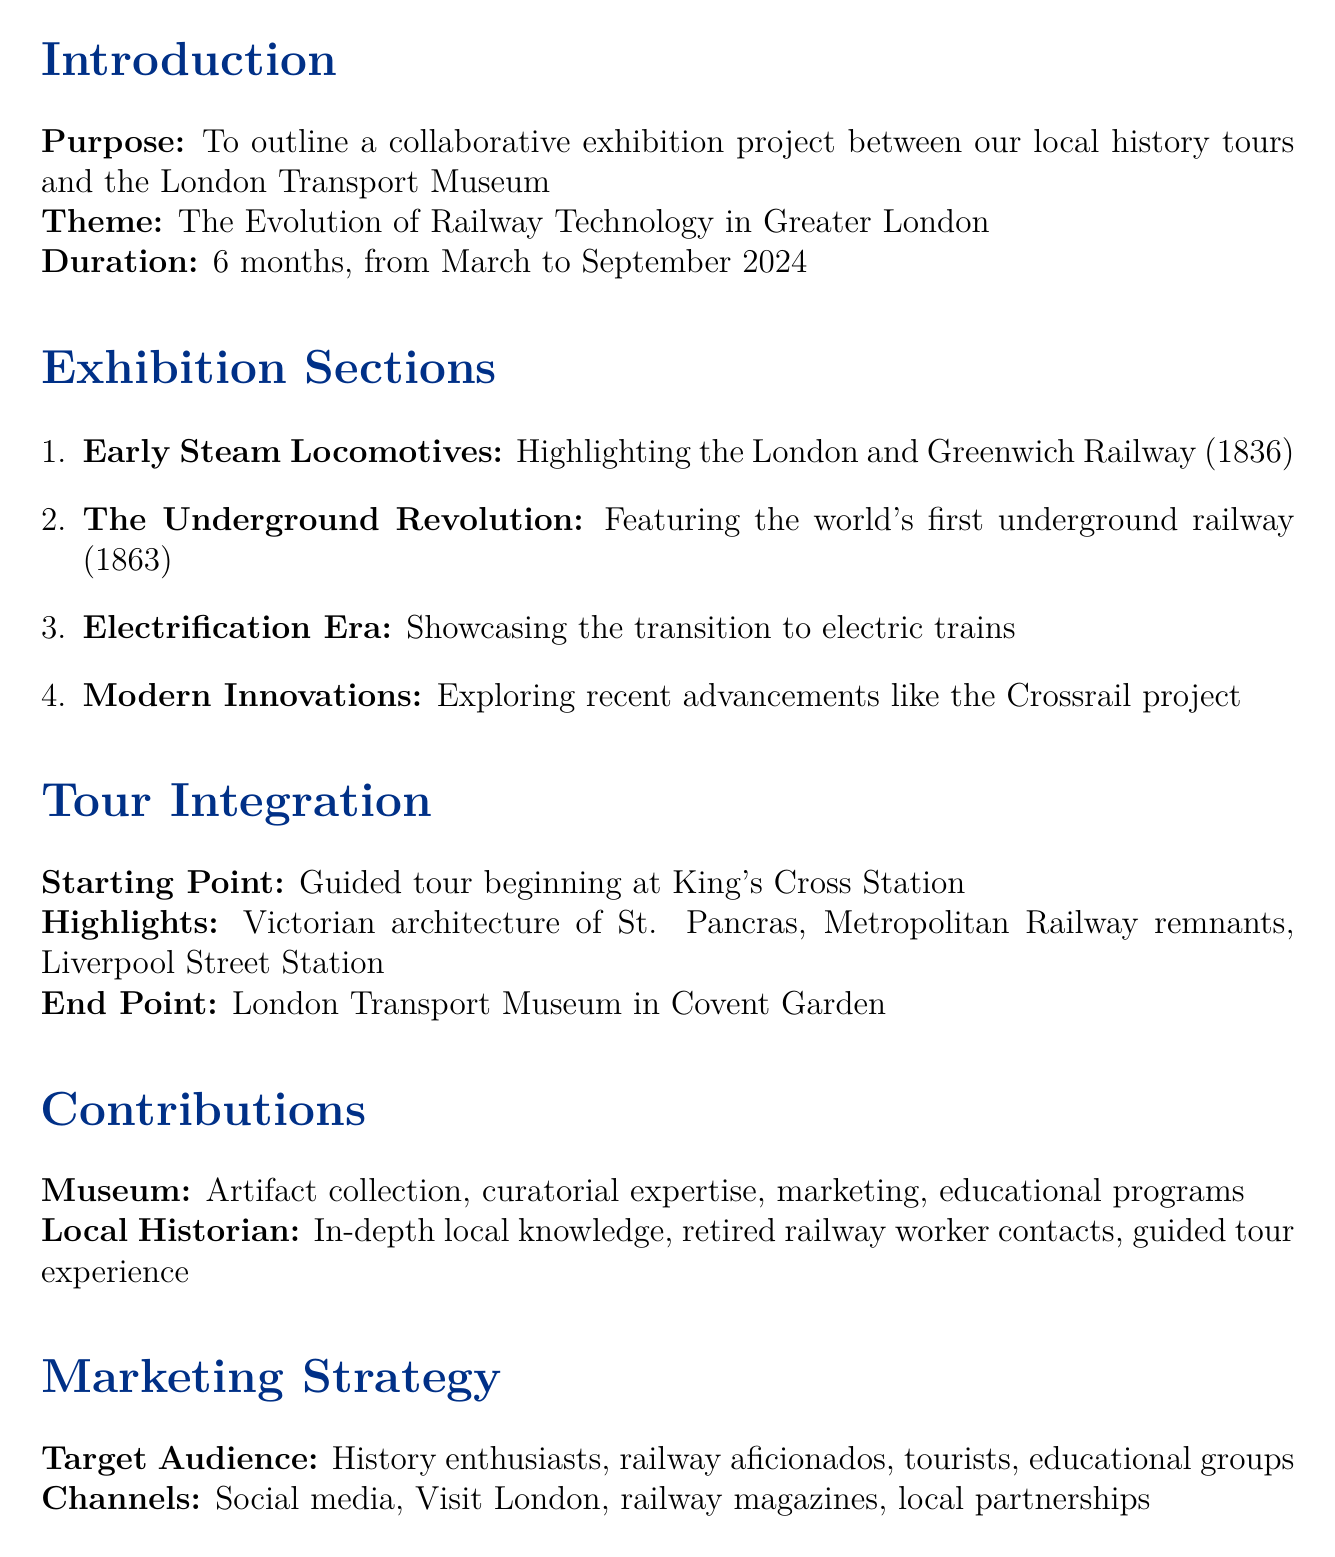What is the purpose of the memo? The purpose of the memo is to outline a collaborative exhibition project between our local history tours and the London Transport Museum.
Answer: To outline a collaborative exhibition project What is the theme of the exhibition? The theme of the exhibition is the specific subject matter that will be displayed during the project.
Answer: The Evolution of Railway Technology in Greater London When will the exhibition take place? The duration mentioned in the document indicates the specific months during which the exhibition will run.
Answer: From March to September 2024 What is one key artifact from the "Electrification Era" section? The key artifact represents a significant piece of technology relevant to that section of the exhibition.
Answer: Control panel from the City and South London Railway Where does the guided tour start? The starting point provides the location where participants will begin their guided tour.
Answer: King's Cross Station What is the estimated cost for the exhibition? The estimated costs mentioned indicate the financial requirement for setting up the exhibition.
Answer: £150,000 Which month marks the beginning of the planning phase? The planning phase timeline specifies when activities related to planning will commence.
Answer: November 2023 Who is a potential sponsor mentioned in the document? The document lists organizations that may provide financial support for the exhibition.
Answer: Network Rail What is one expected outcome of the collaboration? The expected outcomes mention the benefits anticipated from the joint effort between the museum and local historians.
Answer: Increased public awareness of local railway heritage 